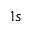Convert formula to latex. <formula><loc_0><loc_0><loc_500><loc_500>1 s</formula> 